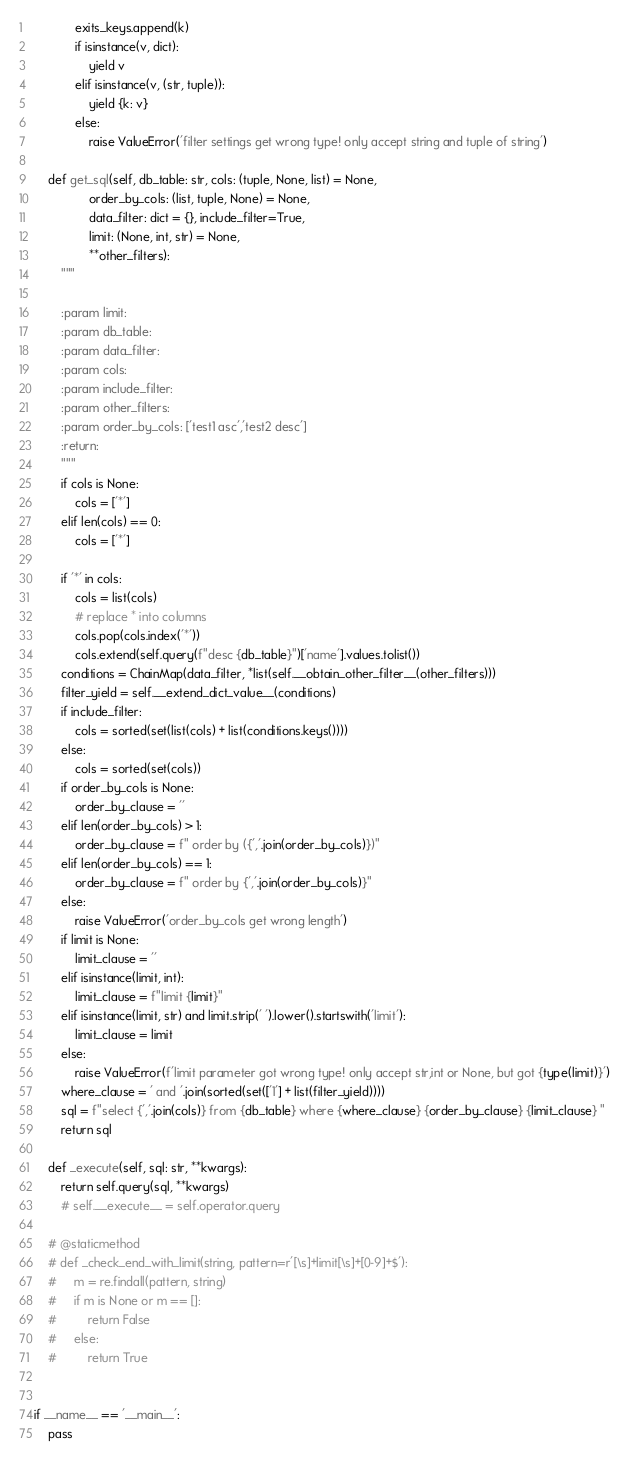<code> <loc_0><loc_0><loc_500><loc_500><_Python_>            exits_keys.append(k)
            if isinstance(v, dict):
                yield v
            elif isinstance(v, (str, tuple)):
                yield {k: v}
            else:
                raise ValueError('filter settings get wrong type! only accept string and tuple of string')

    def get_sql(self, db_table: str, cols: (tuple, None, list) = None,
                order_by_cols: (list, tuple, None) = None,
                data_filter: dict = {}, include_filter=True,
                limit: (None, int, str) = None,
                **other_filters):
        """

        :param limit:
        :param db_table:
        :param data_filter:
        :param cols:
        :param include_filter:
        :param other_filters:
        :param order_by_cols: ['test1 asc','test2 desc']
        :return:
        """
        if cols is None:
            cols = ['*']
        elif len(cols) == 0:
            cols = ['*']

        if '*' in cols:
            cols = list(cols)
            # replace * into columns
            cols.pop(cols.index('*'))
            cols.extend(self.query(f"desc {db_table}")['name'].values.tolist())
        conditions = ChainMap(data_filter, *list(self.__obtain_other_filter__(other_filters)))
        filter_yield = self.__extend_dict_value__(conditions)
        if include_filter:
            cols = sorted(set(list(cols) + list(conditions.keys())))
        else:
            cols = sorted(set(cols))
        if order_by_cols is None:
            order_by_clause = ''
        elif len(order_by_cols) > 1:
            order_by_clause = f" order by ({','.join(order_by_cols)})"
        elif len(order_by_cols) == 1:
            order_by_clause = f" order by {','.join(order_by_cols)}"
        else:
            raise ValueError('order_by_cols get wrong length')
        if limit is None:
            limit_clause = ''
        elif isinstance(limit, int):
            limit_clause = f"limit {limit}"
        elif isinstance(limit, str) and limit.strip(' ').lower().startswith('limit'):
            limit_clause = limit
        else:
            raise ValueError(f'limit parameter got wrong type! only accept str,int or None, but got {type(limit)}')
        where_clause = ' and '.join(sorted(set(['1'] + list(filter_yield))))
        sql = f"select {','.join(cols)} from {db_table} where {where_clause} {order_by_clause} {limit_clause} "
        return sql

    def _execute(self, sql: str, **kwargs):
        return self.query(sql, **kwargs)
        # self.__execute__ = self.operator.query

    # @staticmethod
    # def _check_end_with_limit(string, pattern=r'[\s]+limit[\s]+[0-9]+$'):
    #     m = re.findall(pattern, string)
    #     if m is None or m == []:
    #         return False
    #     else:
    #         return True


if __name__ == '__main__':
    pass
</code> 